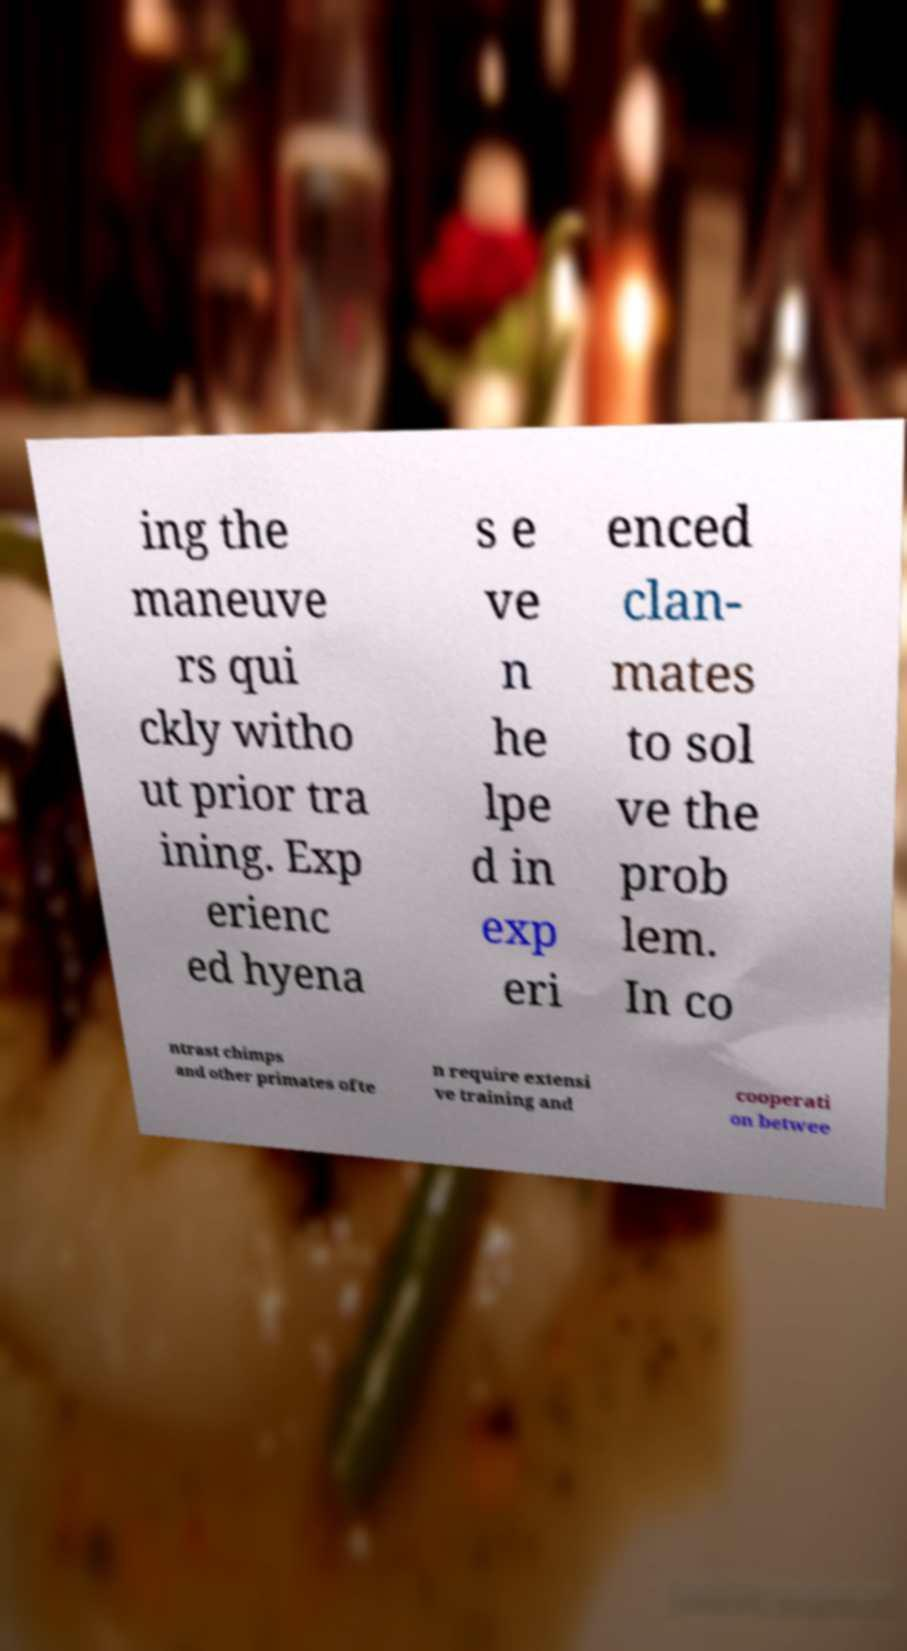Can you read and provide the text displayed in the image?This photo seems to have some interesting text. Can you extract and type it out for me? ing the maneuve rs qui ckly witho ut prior tra ining. Exp erienc ed hyena s e ve n he lpe d in exp eri enced clan- mates to sol ve the prob lem. In co ntrast chimps and other primates ofte n require extensi ve training and cooperati on betwee 